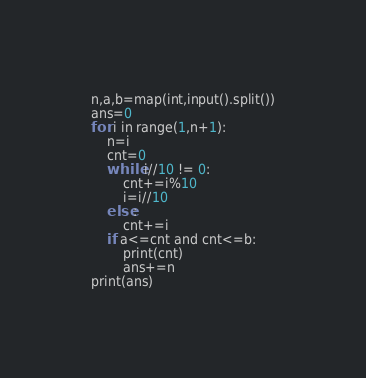Convert code to text. <code><loc_0><loc_0><loc_500><loc_500><_Python_>n,a,b=map(int,input().split())
ans=0
for i in range(1,n+1):
    n=i
    cnt=0
    while i//10 != 0:
        cnt+=i%10
        i=i//10
    else:
        cnt+=i
    if a<=cnt and cnt<=b:
        print(cnt)
        ans+=n
print(ans)</code> 